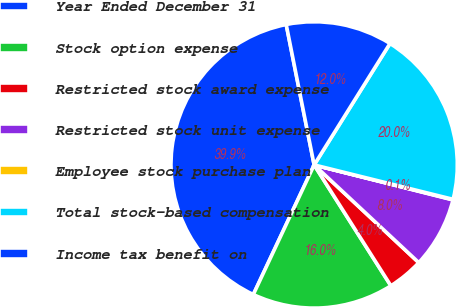Convert chart. <chart><loc_0><loc_0><loc_500><loc_500><pie_chart><fcel>Year Ended December 31<fcel>Stock option expense<fcel>Restricted stock award expense<fcel>Restricted stock unit expense<fcel>Employee stock purchase plan<fcel>Total stock-based compensation<fcel>Income tax benefit on<nl><fcel>39.89%<fcel>15.99%<fcel>4.04%<fcel>8.03%<fcel>0.06%<fcel>19.98%<fcel>12.01%<nl></chart> 